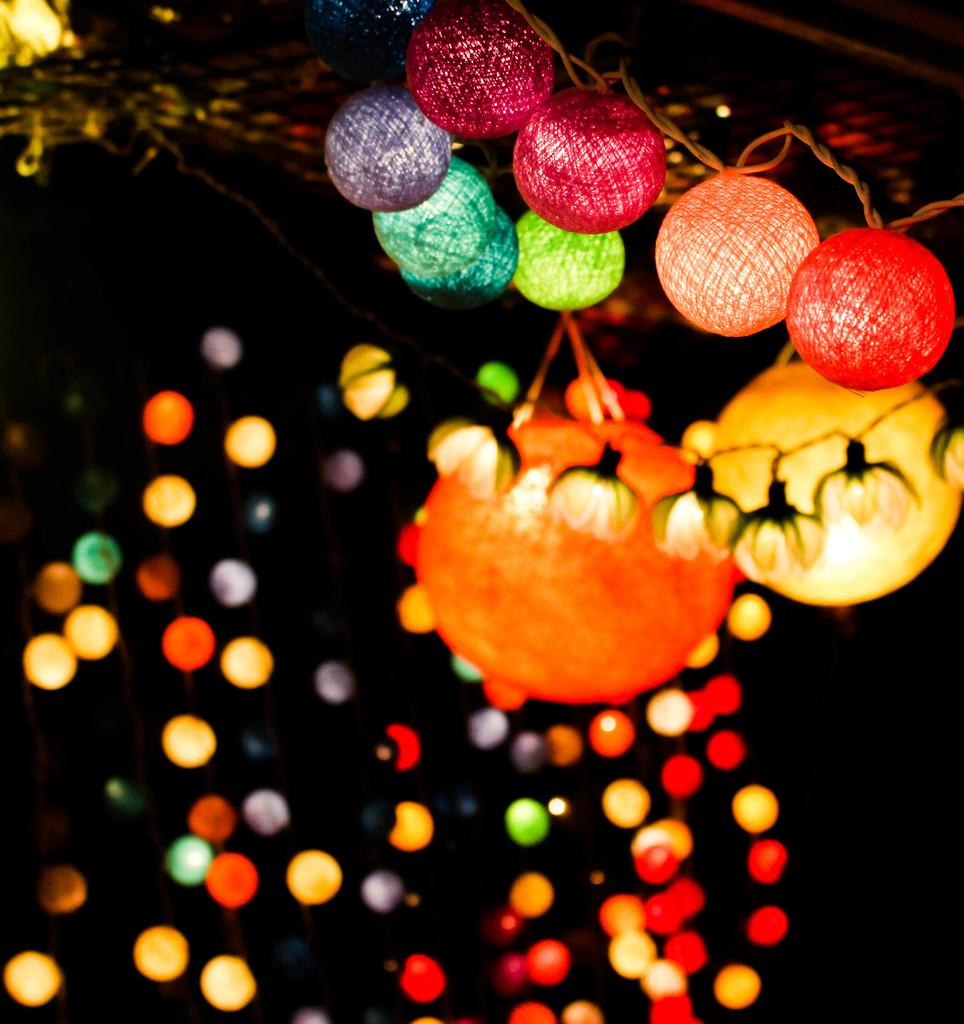What type of illumination is present in the image? The image contains lights. What type of church can be seen in the image? There is no church present in the image; it only contains lights. What kind of ball is being used in the image? There is no ball present in the image; it only contains lights. 